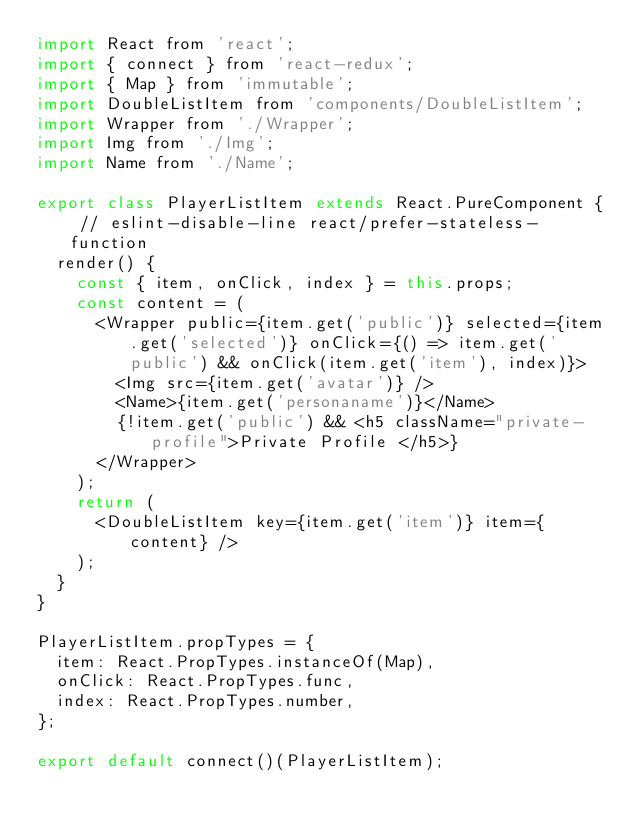<code> <loc_0><loc_0><loc_500><loc_500><_JavaScript_>import React from 'react';
import { connect } from 'react-redux';
import { Map } from 'immutable';
import DoubleListItem from 'components/DoubleListItem';
import Wrapper from './Wrapper';
import Img from './Img';
import Name from './Name';

export class PlayerListItem extends React.PureComponent { // eslint-disable-line react/prefer-stateless-function
  render() {
    const { item, onClick, index } = this.props;
    const content = (
      <Wrapper public={item.get('public')} selected={item.get('selected')} onClick={() => item.get('public') && onClick(item.get('item'), index)}>
        <Img src={item.get('avatar')} />
        <Name>{item.get('personaname')}</Name>
        {!item.get('public') && <h5 className="private-profile">Private Profile </h5>}
      </Wrapper>
    );
    return (
      <DoubleListItem key={item.get('item')} item={content} />
    );
  }
}

PlayerListItem.propTypes = {
  item: React.PropTypes.instanceOf(Map),
  onClick: React.PropTypes.func,
  index: React.PropTypes.number,
};

export default connect()(PlayerListItem);
</code> 